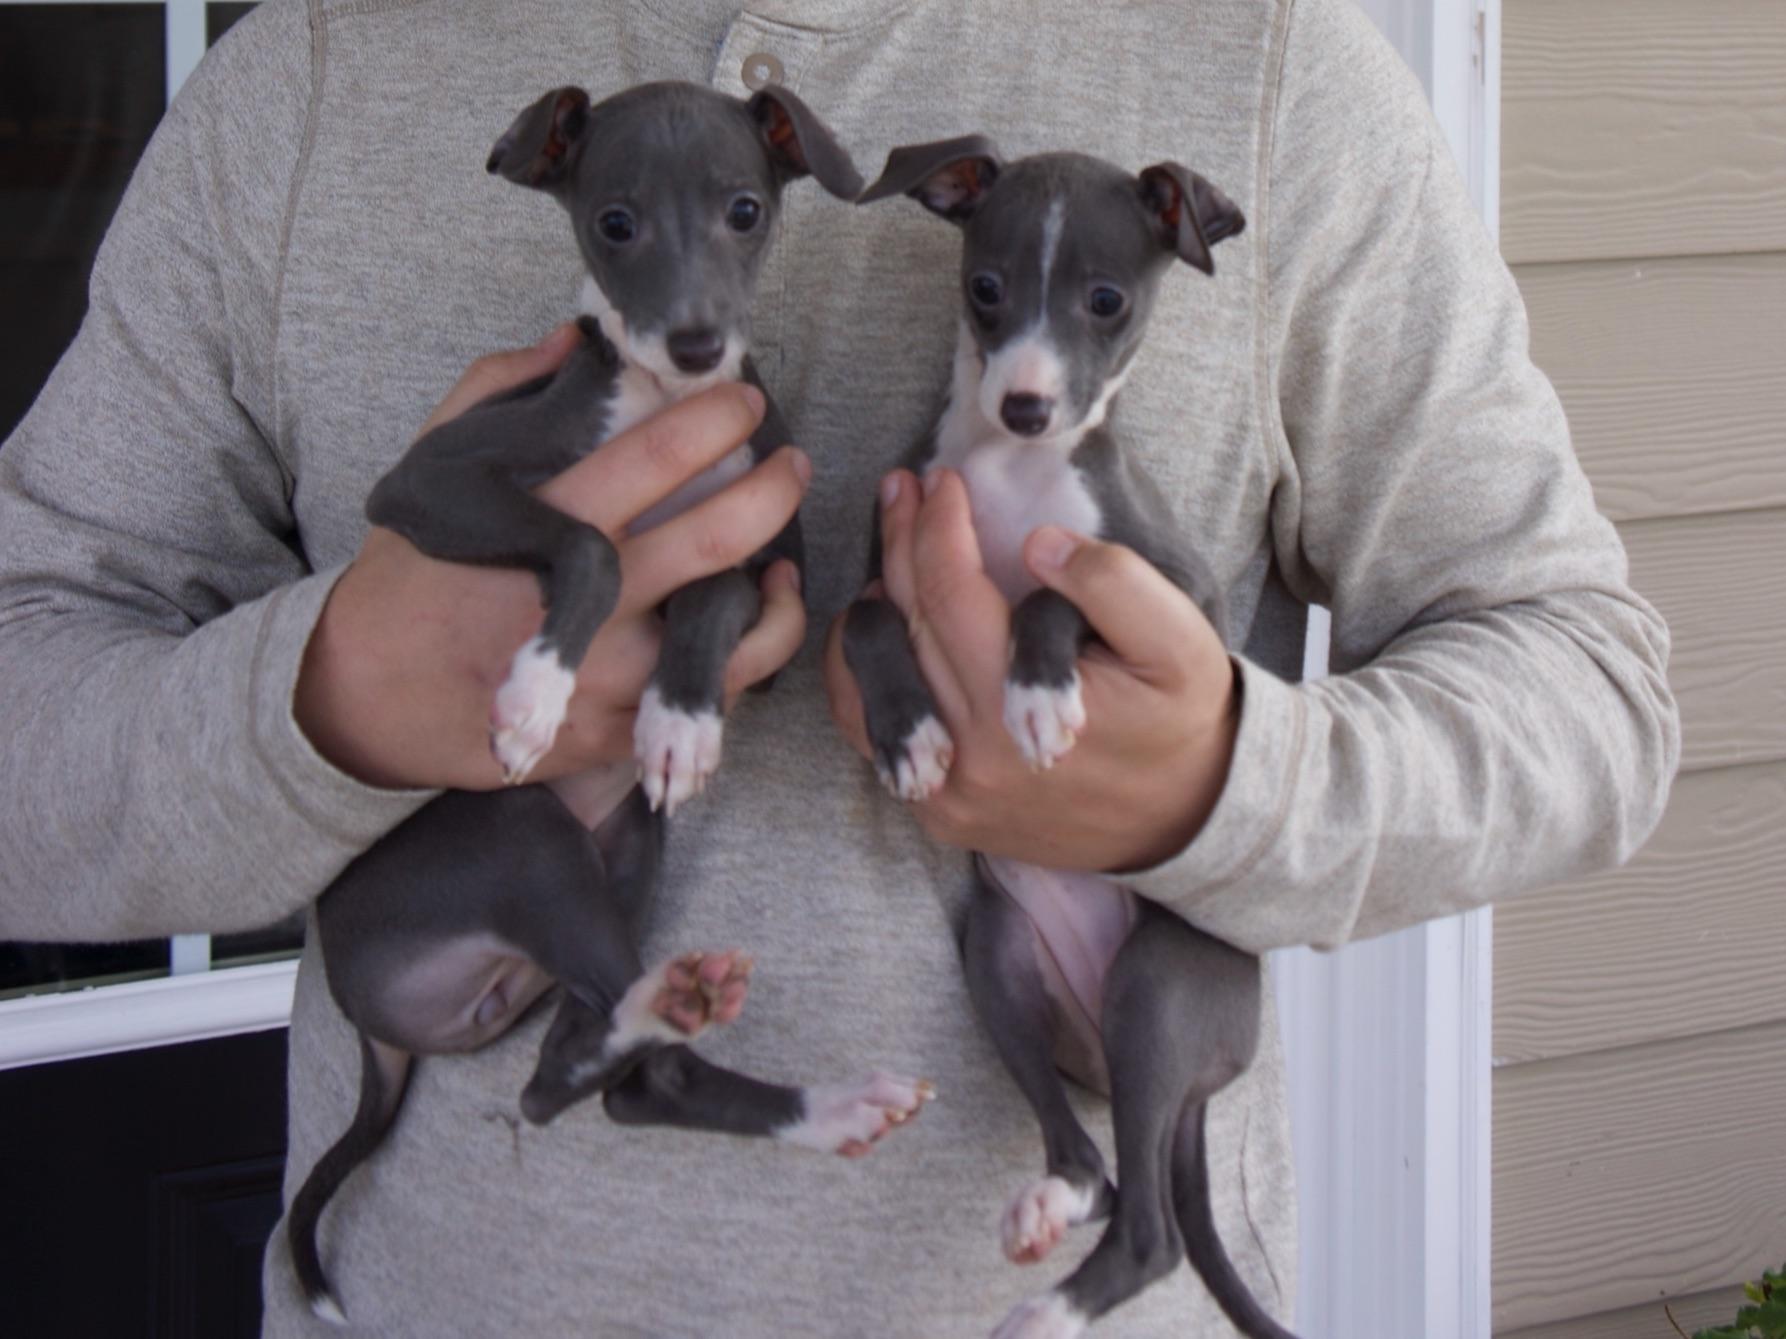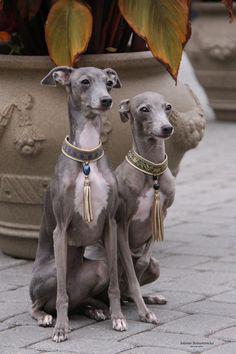The first image is the image on the left, the second image is the image on the right. Considering the images on both sides, is "In total, four dogs are shown." valid? Answer yes or no. Yes. The first image is the image on the left, the second image is the image on the right. Examine the images to the left and right. Is the description "In one image, a person is holding at least one little dog." accurate? Answer yes or no. Yes. 